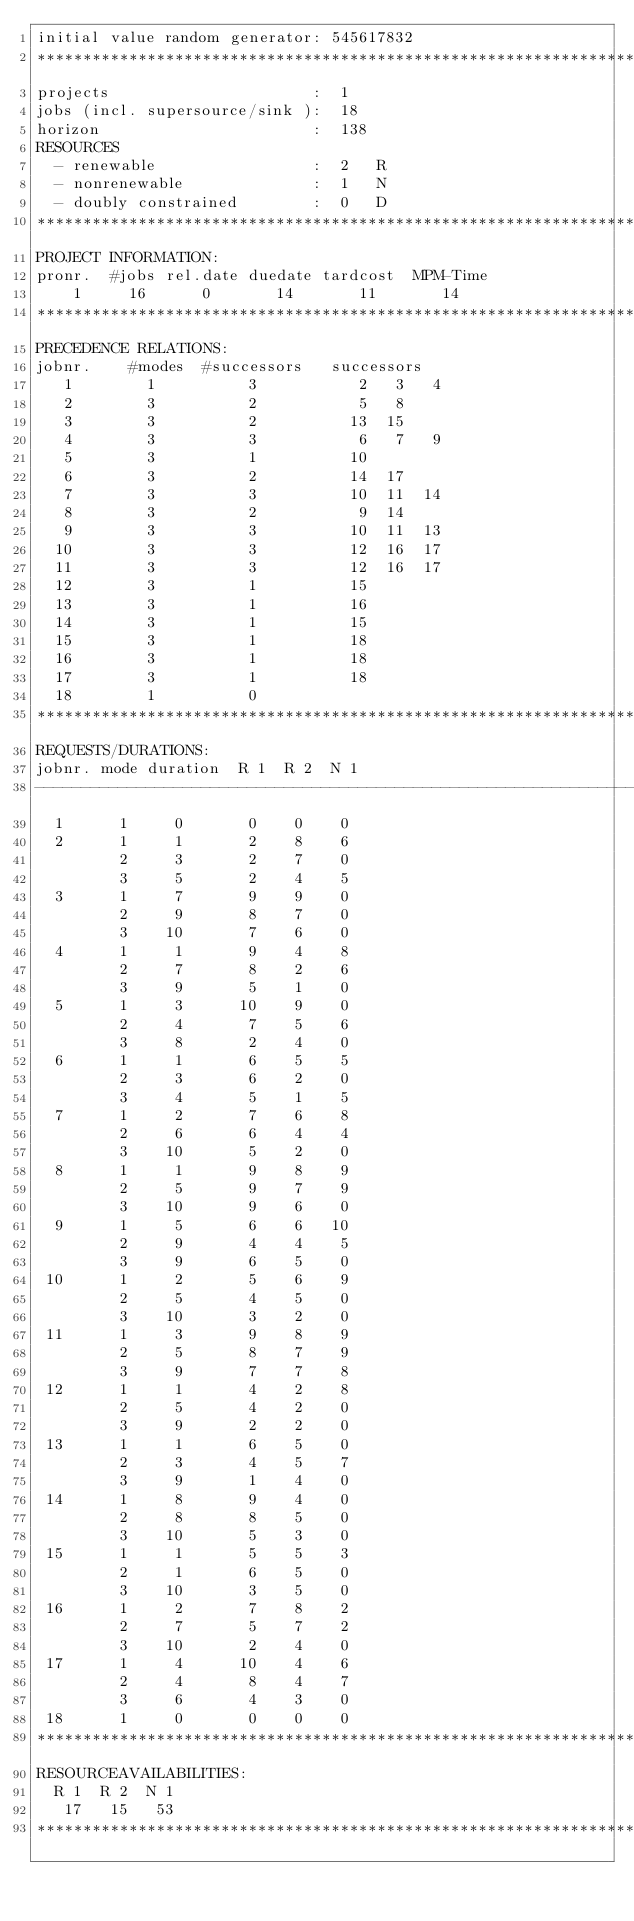<code> <loc_0><loc_0><loc_500><loc_500><_ObjectiveC_>initial value random generator: 545617832
************************************************************************
projects                      :  1
jobs (incl. supersource/sink ):  18
horizon                       :  138
RESOURCES
  - renewable                 :  2   R
  - nonrenewable              :  1   N
  - doubly constrained        :  0   D
************************************************************************
PROJECT INFORMATION:
pronr.  #jobs rel.date duedate tardcost  MPM-Time
    1     16      0       14       11       14
************************************************************************
PRECEDENCE RELATIONS:
jobnr.    #modes  #successors   successors
   1        1          3           2   3   4
   2        3          2           5   8
   3        3          2          13  15
   4        3          3           6   7   9
   5        3          1          10
   6        3          2          14  17
   7        3          3          10  11  14
   8        3          2           9  14
   9        3          3          10  11  13
  10        3          3          12  16  17
  11        3          3          12  16  17
  12        3          1          15
  13        3          1          16
  14        3          1          15
  15        3          1          18
  16        3          1          18
  17        3          1          18
  18        1          0        
************************************************************************
REQUESTS/DURATIONS:
jobnr. mode duration  R 1  R 2  N 1
------------------------------------------------------------------------
  1      1     0       0    0    0
  2      1     1       2    8    6
         2     3       2    7    0
         3     5       2    4    5
  3      1     7       9    9    0
         2     9       8    7    0
         3    10       7    6    0
  4      1     1       9    4    8
         2     7       8    2    6
         3     9       5    1    0
  5      1     3      10    9    0
         2     4       7    5    6
         3     8       2    4    0
  6      1     1       6    5    5
         2     3       6    2    0
         3     4       5    1    5
  7      1     2       7    6    8
         2     6       6    4    4
         3    10       5    2    0
  8      1     1       9    8    9
         2     5       9    7    9
         3    10       9    6    0
  9      1     5       6    6   10
         2     9       4    4    5
         3     9       6    5    0
 10      1     2       5    6    9
         2     5       4    5    0
         3    10       3    2    0
 11      1     3       9    8    9
         2     5       8    7    9
         3     9       7    7    8
 12      1     1       4    2    8
         2     5       4    2    0
         3     9       2    2    0
 13      1     1       6    5    0
         2     3       4    5    7
         3     9       1    4    0
 14      1     8       9    4    0
         2     8       8    5    0
         3    10       5    3    0
 15      1     1       5    5    3
         2     1       6    5    0
         3    10       3    5    0
 16      1     2       7    8    2
         2     7       5    7    2
         3    10       2    4    0
 17      1     4      10    4    6
         2     4       8    4    7
         3     6       4    3    0
 18      1     0       0    0    0
************************************************************************
RESOURCEAVAILABILITIES:
  R 1  R 2  N 1
   17   15   53
************************************************************************
</code> 